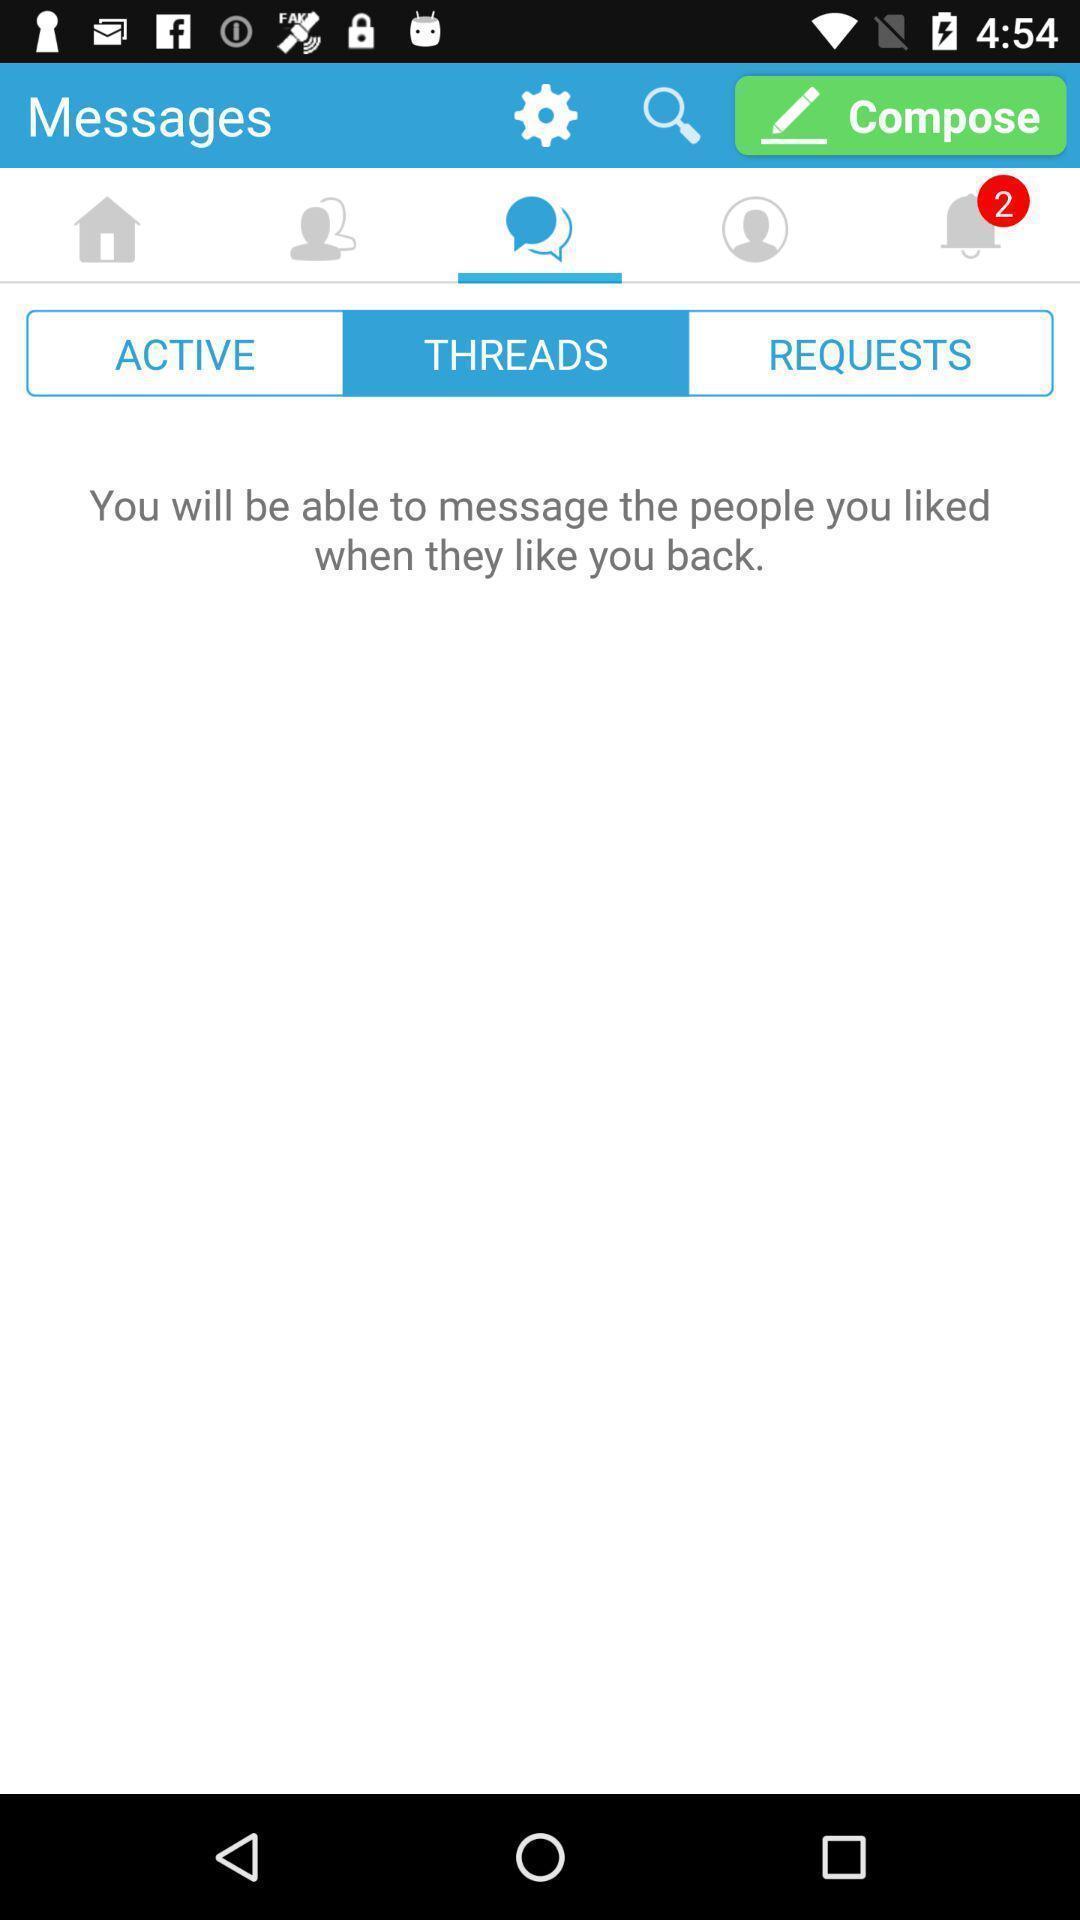Provide a textual representation of this image. Screen showing threads. 